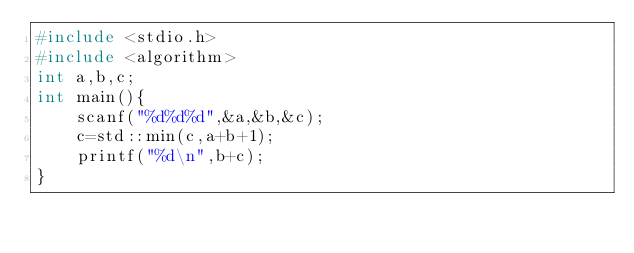Convert code to text. <code><loc_0><loc_0><loc_500><loc_500><_C++_>#include <stdio.h>
#include <algorithm>
int a,b,c;
int main(){
	scanf("%d%d%d",&a,&b,&c);
	c=std::min(c,a+b+1);
	printf("%d\n",b+c);
}</code> 